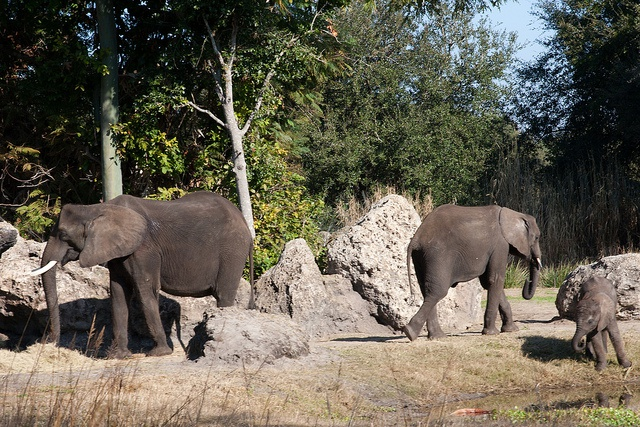Describe the objects in this image and their specific colors. I can see elephant in black and gray tones, elephant in black, gray, and darkgray tones, and elephant in black, gray, and darkgray tones in this image. 